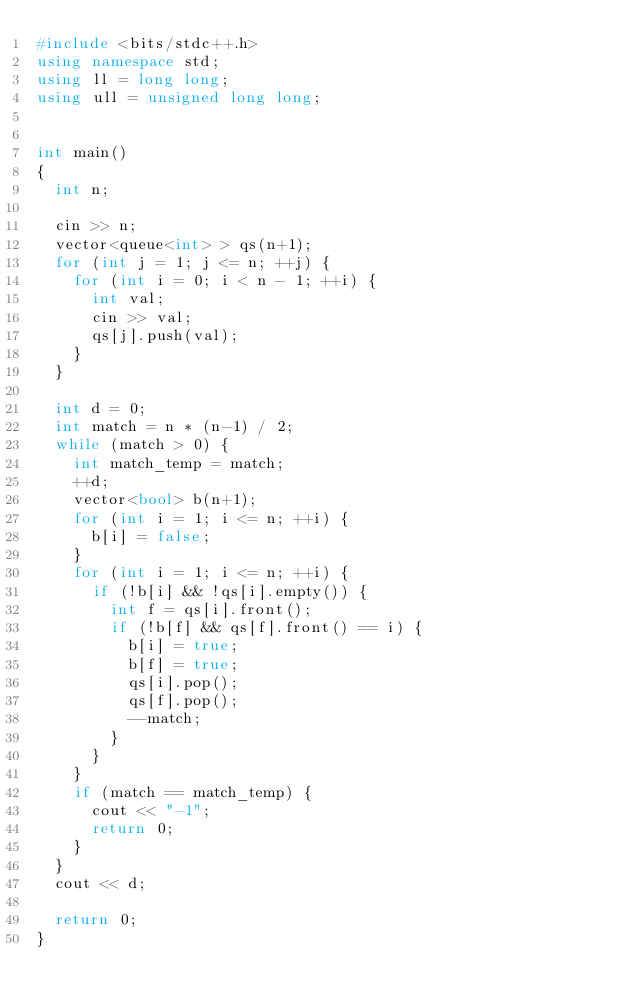Convert code to text. <code><loc_0><loc_0><loc_500><loc_500><_C++_>#include <bits/stdc++.h>
using namespace std;
using ll = long long;
using ull = unsigned long long;


int main()
{
  int n;

  cin >> n;
  vector<queue<int> > qs(n+1);
  for (int j = 1; j <= n; ++j) {
    for (int i = 0; i < n - 1; ++i) {
      int val;
      cin >> val;
      qs[j].push(val);
    }
  }

  int d = 0;
  int match = n * (n-1) / 2;
  while (match > 0) {
    int match_temp = match;
    ++d;
    vector<bool> b(n+1);
    for (int i = 1; i <= n; ++i) {
      b[i] = false;
    }
    for (int i = 1; i <= n; ++i) {
      if (!b[i] && !qs[i].empty()) {
        int f = qs[i].front();
        if (!b[f] && qs[f].front() == i) {
          b[i] = true;
          b[f] = true;
          qs[i].pop();
          qs[f].pop();
          --match;
        }
      }
    }
    if (match == match_temp) {
      cout << "-1";
      return 0;
    }
  }
  cout << d;
  
  return 0;
}

</code> 